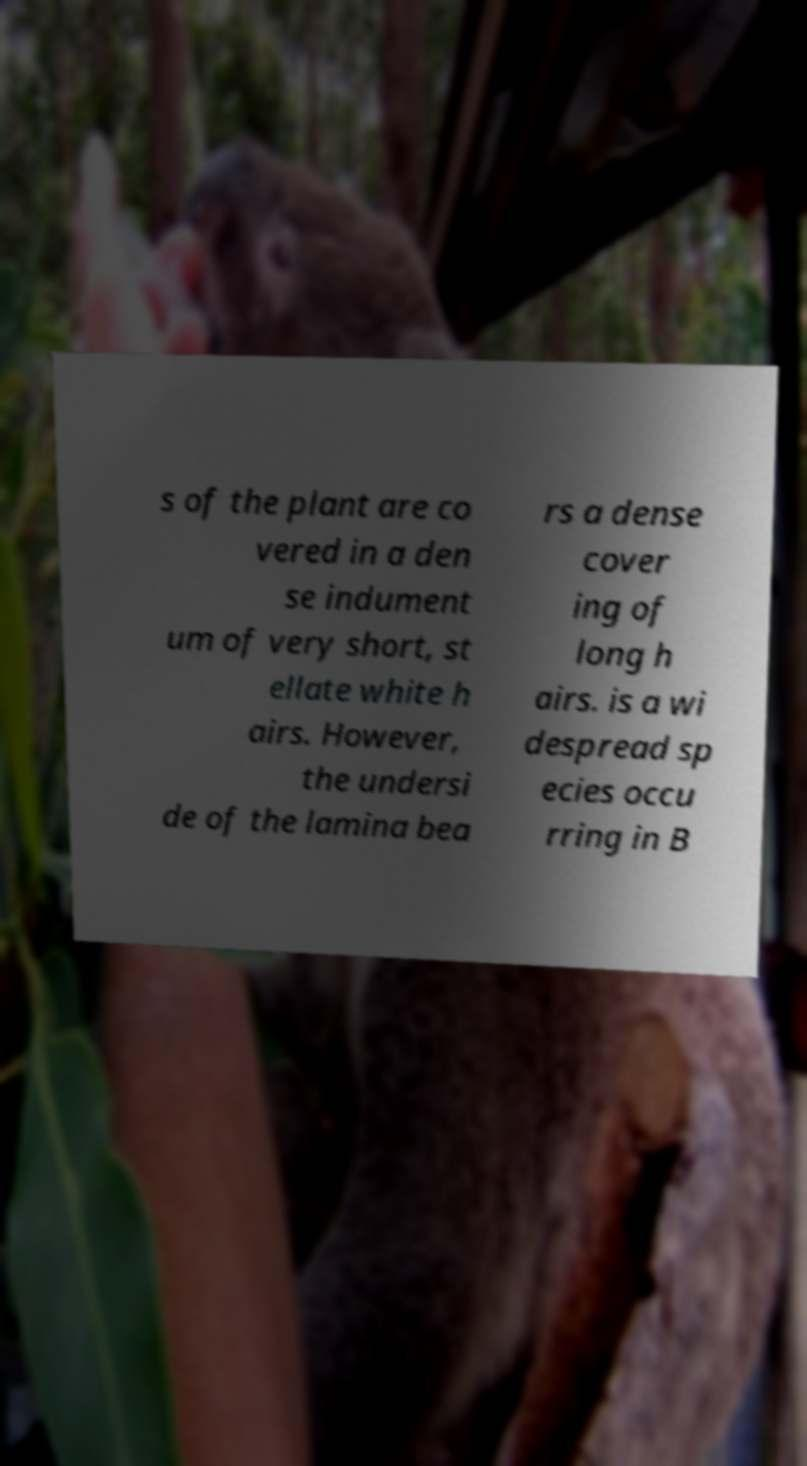For documentation purposes, I need the text within this image transcribed. Could you provide that? s of the plant are co vered in a den se indument um of very short, st ellate white h airs. However, the undersi de of the lamina bea rs a dense cover ing of long h airs. is a wi despread sp ecies occu rring in B 